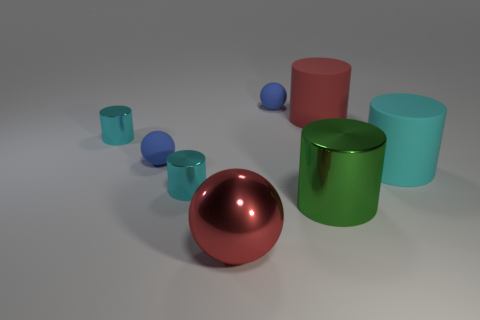How many cyan cylinders must be subtracted to get 1 cyan cylinders? 2 Subtract all blue cylinders. How many blue spheres are left? 2 Subtract all green cylinders. How many cylinders are left? 4 Subtract all cyan matte cylinders. How many cylinders are left? 4 Add 2 large shiny balls. How many objects exist? 10 Subtract 2 cylinders. How many cylinders are left? 3 Subtract all gray cylinders. Subtract all purple blocks. How many cylinders are left? 5 Subtract all cylinders. How many objects are left? 3 Add 1 big red objects. How many big red objects exist? 3 Subtract 0 purple cubes. How many objects are left? 8 